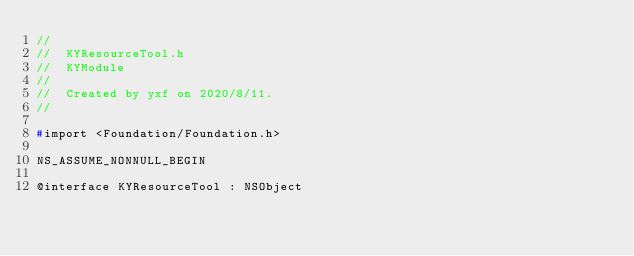<code> <loc_0><loc_0><loc_500><loc_500><_C_>//
//  KYResourceTool.h
//  KYModule
//
//  Created by yxf on 2020/8/11.
//

#import <Foundation/Foundation.h>

NS_ASSUME_NONNULL_BEGIN

@interface KYResourceTool : NSObject
</code> 